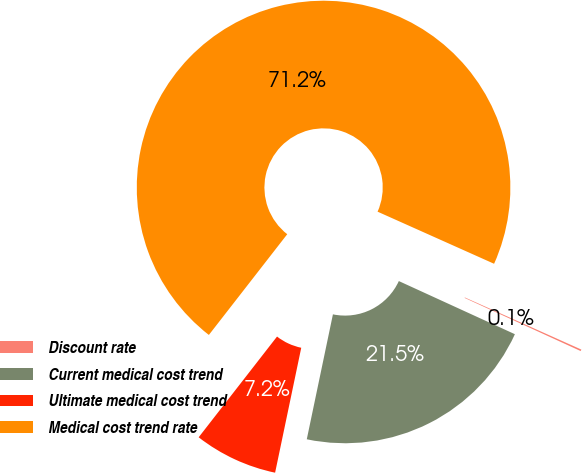<chart> <loc_0><loc_0><loc_500><loc_500><pie_chart><fcel>Discount rate<fcel>Current medical cost trend<fcel>Ultimate medical cost trend<fcel>Medical cost trend rate<nl><fcel>0.14%<fcel>21.45%<fcel>7.24%<fcel>71.17%<nl></chart> 